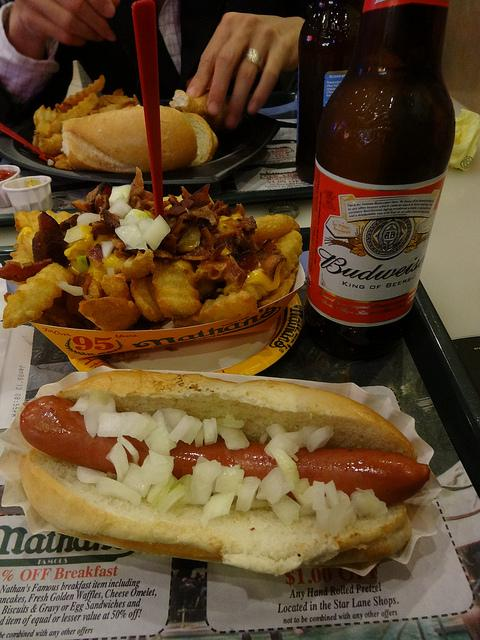Consuming which one of these items will make it dangerous to drive?

Choices:
A) in box
B) in bottle
C) on plate
D) in bun in bottle 